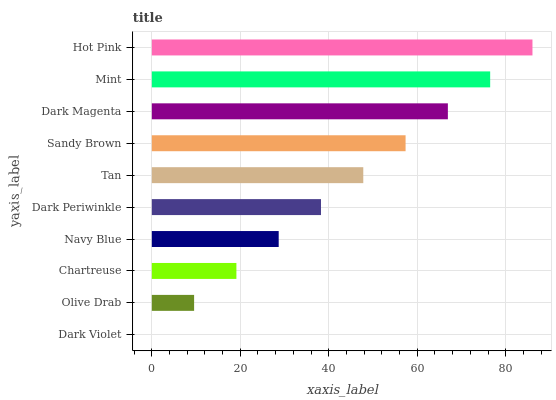Is Dark Violet the minimum?
Answer yes or no. Yes. Is Hot Pink the maximum?
Answer yes or no. Yes. Is Olive Drab the minimum?
Answer yes or no. No. Is Olive Drab the maximum?
Answer yes or no. No. Is Olive Drab greater than Dark Violet?
Answer yes or no. Yes. Is Dark Violet less than Olive Drab?
Answer yes or no. Yes. Is Dark Violet greater than Olive Drab?
Answer yes or no. No. Is Olive Drab less than Dark Violet?
Answer yes or no. No. Is Tan the high median?
Answer yes or no. Yes. Is Dark Periwinkle the low median?
Answer yes or no. Yes. Is Chartreuse the high median?
Answer yes or no. No. Is Dark Violet the low median?
Answer yes or no. No. 